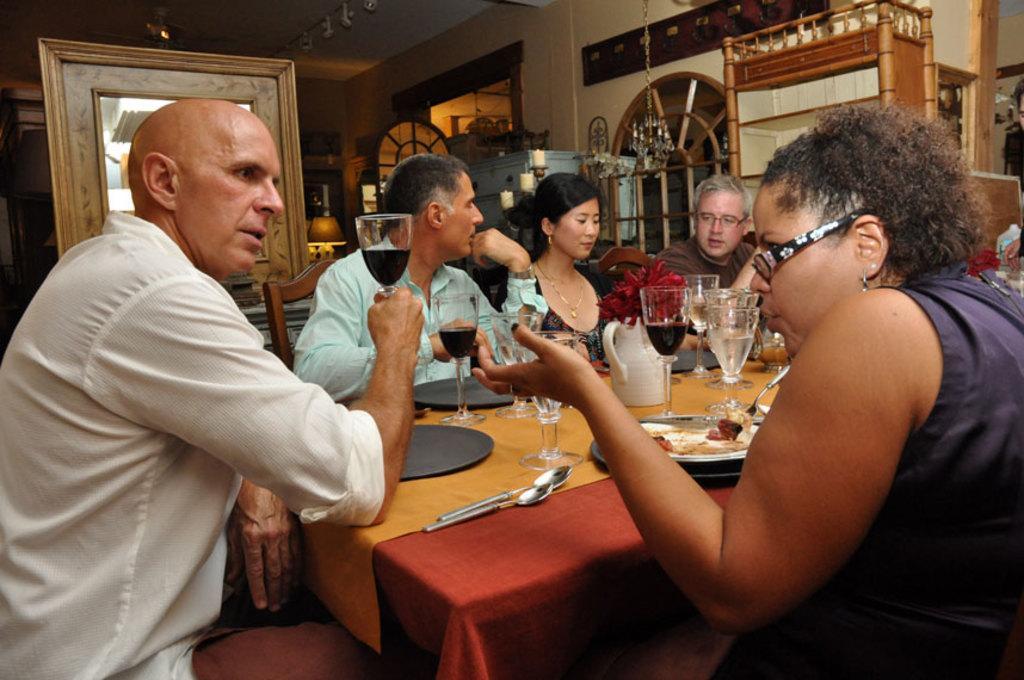How would you summarize this image in a sentence or two? There are group of people sitting in chairs and there is a table in front of them which has some eatables and drinks on it. 